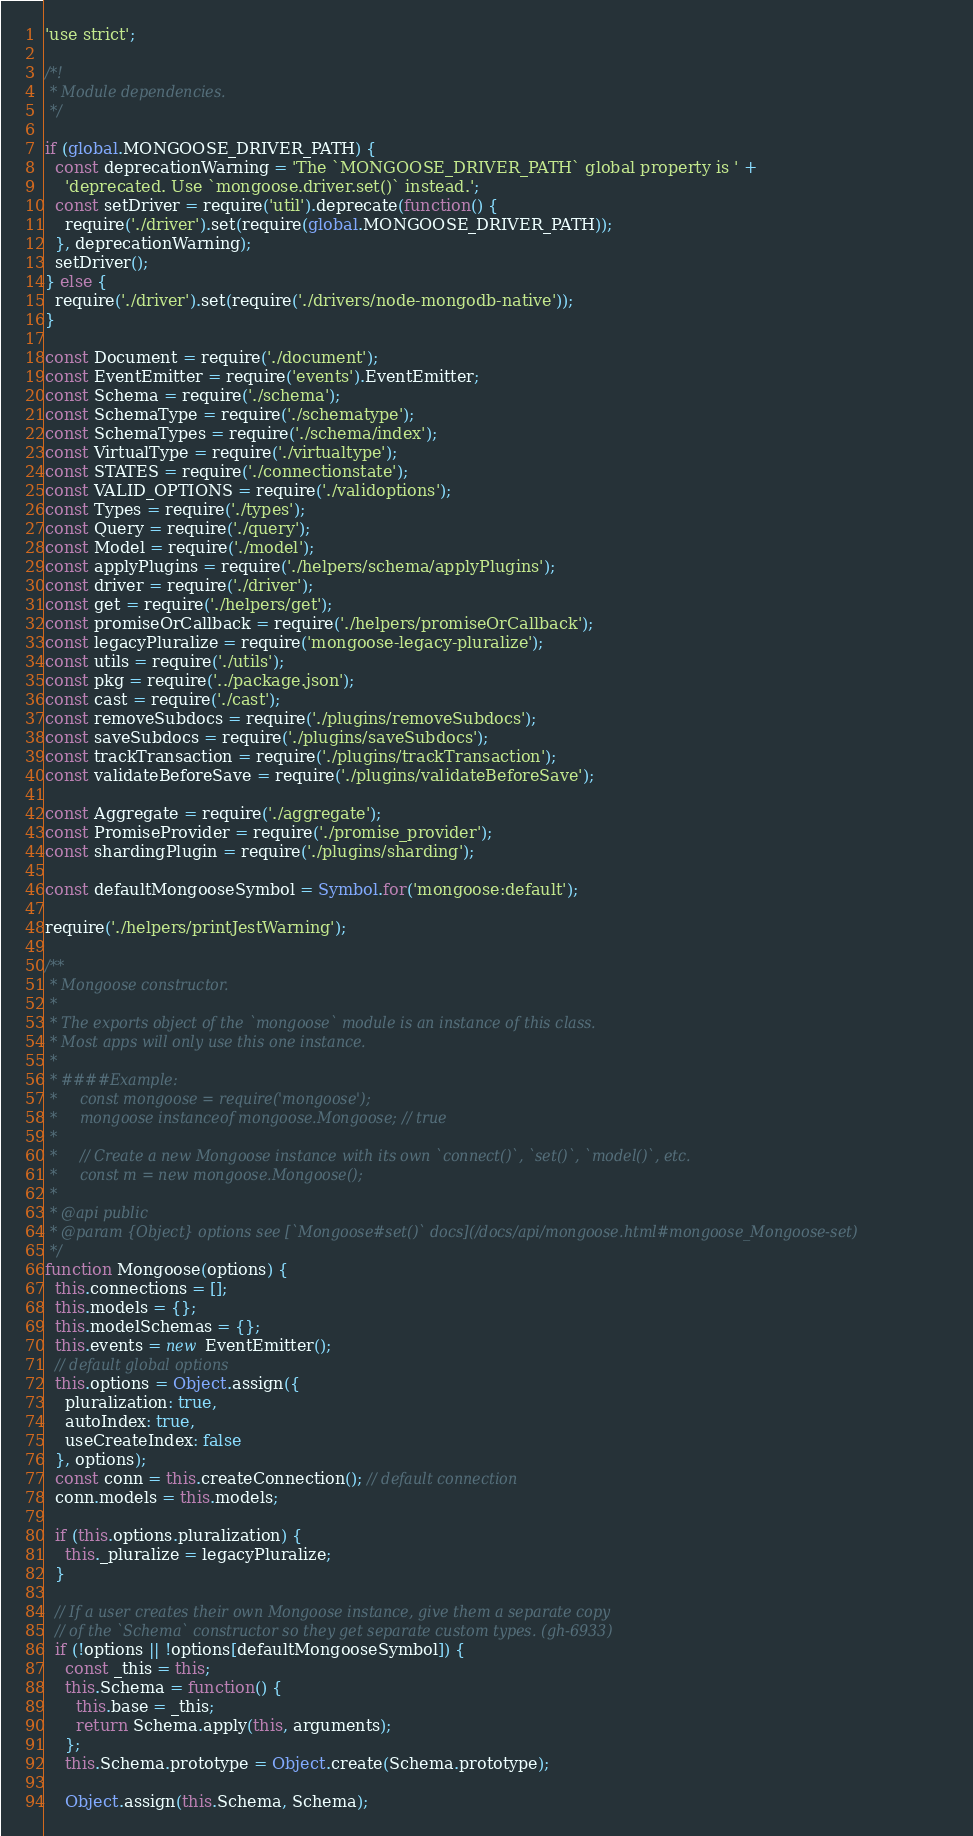Convert code to text. <code><loc_0><loc_0><loc_500><loc_500><_JavaScript_>'use strict';

/*!
 * Module dependencies.
 */

if (global.MONGOOSE_DRIVER_PATH) {
  const deprecationWarning = 'The `MONGOOSE_DRIVER_PATH` global property is ' +
    'deprecated. Use `mongoose.driver.set()` instead.';
  const setDriver = require('util').deprecate(function() {
    require('./driver').set(require(global.MONGOOSE_DRIVER_PATH));
  }, deprecationWarning);
  setDriver();
} else {
  require('./driver').set(require('./drivers/node-mongodb-native'));
}

const Document = require('./document');
const EventEmitter = require('events').EventEmitter;
const Schema = require('./schema');
const SchemaType = require('./schematype');
const SchemaTypes = require('./schema/index');
const VirtualType = require('./virtualtype');
const STATES = require('./connectionstate');
const VALID_OPTIONS = require('./validoptions');
const Types = require('./types');
const Query = require('./query');
const Model = require('./model');
const applyPlugins = require('./helpers/schema/applyPlugins');
const driver = require('./driver');
const get = require('./helpers/get');
const promiseOrCallback = require('./helpers/promiseOrCallback');
const legacyPluralize = require('mongoose-legacy-pluralize');
const utils = require('./utils');
const pkg = require('../package.json');
const cast = require('./cast');
const removeSubdocs = require('./plugins/removeSubdocs');
const saveSubdocs = require('./plugins/saveSubdocs');
const trackTransaction = require('./plugins/trackTransaction');
const validateBeforeSave = require('./plugins/validateBeforeSave');

const Aggregate = require('./aggregate');
const PromiseProvider = require('./promise_provider');
const shardingPlugin = require('./plugins/sharding');

const defaultMongooseSymbol = Symbol.for('mongoose:default');

require('./helpers/printJestWarning');

/**
 * Mongoose constructor.
 *
 * The exports object of the `mongoose` module is an instance of this class.
 * Most apps will only use this one instance.
 *
 * ####Example:
 *     const mongoose = require('mongoose');
 *     mongoose instanceof mongoose.Mongoose; // true
 *
 *     // Create a new Mongoose instance with its own `connect()`, `set()`, `model()`, etc.
 *     const m = new mongoose.Mongoose();
 *
 * @api public
 * @param {Object} options see [`Mongoose#set()` docs](/docs/api/mongoose.html#mongoose_Mongoose-set)
 */
function Mongoose(options) {
  this.connections = [];
  this.models = {};
  this.modelSchemas = {};
  this.events = new EventEmitter();
  // default global options
  this.options = Object.assign({
    pluralization: true,
    autoIndex: true,
    useCreateIndex: false
  }, options);
  const conn = this.createConnection(); // default connection
  conn.models = this.models;

  if (this.options.pluralization) {
    this._pluralize = legacyPluralize;
  }

  // If a user creates their own Mongoose instance, give them a separate copy
  // of the `Schema` constructor so they get separate custom types. (gh-6933)
  if (!options || !options[defaultMongooseSymbol]) {
    const _this = this;
    this.Schema = function() {
      this.base = _this;
      return Schema.apply(this, arguments);
    };
    this.Schema.prototype = Object.create(Schema.prototype);

    Object.assign(this.Schema, Schema);</code> 